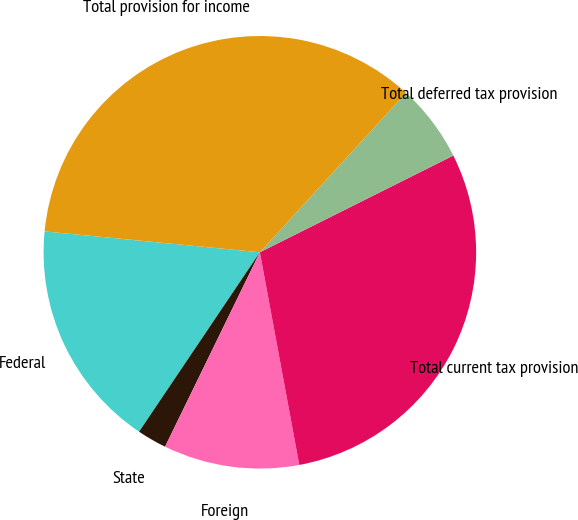Convert chart to OTSL. <chart><loc_0><loc_0><loc_500><loc_500><pie_chart><fcel>Federal<fcel>State<fcel>Foreign<fcel>Total current tax provision<fcel>Total deferred tax provision<fcel>Total provision for income<nl><fcel>17.11%<fcel>2.21%<fcel>10.14%<fcel>29.46%<fcel>5.81%<fcel>35.27%<nl></chart> 